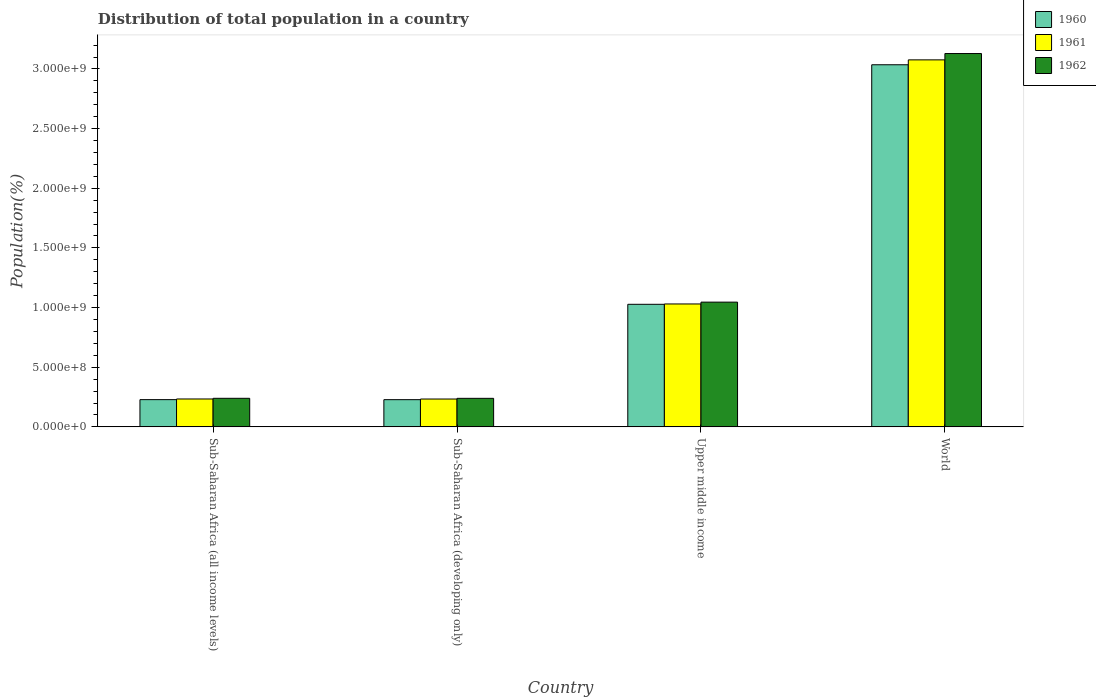Are the number of bars per tick equal to the number of legend labels?
Offer a terse response. Yes. Are the number of bars on each tick of the X-axis equal?
Your answer should be compact. Yes. How many bars are there on the 3rd tick from the left?
Provide a succinct answer. 3. What is the label of the 1st group of bars from the left?
Your response must be concise. Sub-Saharan Africa (all income levels). What is the population of in 1962 in Sub-Saharan Africa (all income levels)?
Your answer should be very brief. 2.39e+08. Across all countries, what is the maximum population of in 1961?
Give a very brief answer. 3.08e+09. Across all countries, what is the minimum population of in 1961?
Provide a short and direct response. 2.33e+08. In which country was the population of in 1960 minimum?
Keep it short and to the point. Sub-Saharan Africa (developing only). What is the total population of in 1961 in the graph?
Offer a terse response. 4.57e+09. What is the difference between the population of in 1960 in Sub-Saharan Africa (developing only) and that in World?
Your response must be concise. -2.81e+09. What is the difference between the population of in 1960 in Sub-Saharan Africa (all income levels) and the population of in 1962 in Sub-Saharan Africa (developing only)?
Your response must be concise. -1.08e+07. What is the average population of in 1961 per country?
Make the answer very short. 1.14e+09. What is the difference between the population of of/in 1962 and population of of/in 1960 in World?
Provide a short and direct response. 9.40e+07. In how many countries, is the population of in 1961 greater than 300000000 %?
Offer a very short reply. 2. What is the ratio of the population of in 1960 in Sub-Saharan Africa (developing only) to that in World?
Your answer should be very brief. 0.08. Is the population of in 1960 in Upper middle income less than that in World?
Ensure brevity in your answer.  Yes. Is the difference between the population of in 1962 in Sub-Saharan Africa (developing only) and World greater than the difference between the population of in 1960 in Sub-Saharan Africa (developing only) and World?
Give a very brief answer. No. What is the difference between the highest and the second highest population of in 1961?
Ensure brevity in your answer.  2.05e+09. What is the difference between the highest and the lowest population of in 1961?
Keep it short and to the point. 2.84e+09. Is the sum of the population of in 1961 in Sub-Saharan Africa (all income levels) and World greater than the maximum population of in 1960 across all countries?
Give a very brief answer. Yes. What does the 2nd bar from the left in Sub-Saharan Africa (all income levels) represents?
Provide a short and direct response. 1961. What does the 2nd bar from the right in Upper middle income represents?
Offer a very short reply. 1961. Are all the bars in the graph horizontal?
Provide a succinct answer. No. How many countries are there in the graph?
Offer a very short reply. 4. What is the difference between two consecutive major ticks on the Y-axis?
Your answer should be compact. 5.00e+08. Are the values on the major ticks of Y-axis written in scientific E-notation?
Your answer should be compact. Yes. Does the graph contain grids?
Your answer should be very brief. No. Where does the legend appear in the graph?
Ensure brevity in your answer.  Top right. What is the title of the graph?
Provide a short and direct response. Distribution of total population in a country. What is the label or title of the Y-axis?
Provide a short and direct response. Population(%). What is the Population(%) of 1960 in Sub-Saharan Africa (all income levels)?
Provide a short and direct response. 2.28e+08. What is the Population(%) of 1961 in Sub-Saharan Africa (all income levels)?
Keep it short and to the point. 2.34e+08. What is the Population(%) of 1962 in Sub-Saharan Africa (all income levels)?
Provide a succinct answer. 2.39e+08. What is the Population(%) of 1960 in Sub-Saharan Africa (developing only)?
Make the answer very short. 2.28e+08. What is the Population(%) of 1961 in Sub-Saharan Africa (developing only)?
Provide a short and direct response. 2.33e+08. What is the Population(%) of 1962 in Sub-Saharan Africa (developing only)?
Your response must be concise. 2.39e+08. What is the Population(%) in 1960 in Upper middle income?
Your answer should be very brief. 1.03e+09. What is the Population(%) of 1961 in Upper middle income?
Offer a very short reply. 1.03e+09. What is the Population(%) in 1962 in Upper middle income?
Your response must be concise. 1.05e+09. What is the Population(%) of 1960 in World?
Keep it short and to the point. 3.03e+09. What is the Population(%) in 1961 in World?
Give a very brief answer. 3.08e+09. What is the Population(%) in 1962 in World?
Ensure brevity in your answer.  3.13e+09. Across all countries, what is the maximum Population(%) in 1960?
Keep it short and to the point. 3.03e+09. Across all countries, what is the maximum Population(%) in 1961?
Offer a very short reply. 3.08e+09. Across all countries, what is the maximum Population(%) in 1962?
Your answer should be compact. 3.13e+09. Across all countries, what is the minimum Population(%) in 1960?
Keep it short and to the point. 2.28e+08. Across all countries, what is the minimum Population(%) of 1961?
Offer a very short reply. 2.33e+08. Across all countries, what is the minimum Population(%) in 1962?
Provide a short and direct response. 2.39e+08. What is the total Population(%) of 1960 in the graph?
Keep it short and to the point. 4.52e+09. What is the total Population(%) of 1961 in the graph?
Ensure brevity in your answer.  4.57e+09. What is the total Population(%) of 1962 in the graph?
Give a very brief answer. 4.65e+09. What is the difference between the Population(%) of 1960 in Sub-Saharan Africa (all income levels) and that in Sub-Saharan Africa (developing only)?
Offer a terse response. 2.94e+05. What is the difference between the Population(%) in 1961 in Sub-Saharan Africa (all income levels) and that in Sub-Saharan Africa (developing only)?
Your response must be concise. 2.98e+05. What is the difference between the Population(%) of 1962 in Sub-Saharan Africa (all income levels) and that in Sub-Saharan Africa (developing only)?
Your response must be concise. 3.02e+05. What is the difference between the Population(%) of 1960 in Sub-Saharan Africa (all income levels) and that in Upper middle income?
Give a very brief answer. -7.99e+08. What is the difference between the Population(%) in 1961 in Sub-Saharan Africa (all income levels) and that in Upper middle income?
Offer a very short reply. -7.96e+08. What is the difference between the Population(%) of 1962 in Sub-Saharan Africa (all income levels) and that in Upper middle income?
Offer a very short reply. -8.06e+08. What is the difference between the Population(%) of 1960 in Sub-Saharan Africa (all income levels) and that in World?
Provide a short and direct response. -2.81e+09. What is the difference between the Population(%) of 1961 in Sub-Saharan Africa (all income levels) and that in World?
Provide a succinct answer. -2.84e+09. What is the difference between the Population(%) of 1962 in Sub-Saharan Africa (all income levels) and that in World?
Give a very brief answer. -2.89e+09. What is the difference between the Population(%) of 1960 in Sub-Saharan Africa (developing only) and that in Upper middle income?
Your answer should be very brief. -7.99e+08. What is the difference between the Population(%) in 1961 in Sub-Saharan Africa (developing only) and that in Upper middle income?
Give a very brief answer. -7.97e+08. What is the difference between the Population(%) in 1962 in Sub-Saharan Africa (developing only) and that in Upper middle income?
Your answer should be very brief. -8.06e+08. What is the difference between the Population(%) in 1960 in Sub-Saharan Africa (developing only) and that in World?
Make the answer very short. -2.81e+09. What is the difference between the Population(%) in 1961 in Sub-Saharan Africa (developing only) and that in World?
Give a very brief answer. -2.84e+09. What is the difference between the Population(%) in 1962 in Sub-Saharan Africa (developing only) and that in World?
Offer a terse response. -2.89e+09. What is the difference between the Population(%) of 1960 in Upper middle income and that in World?
Offer a terse response. -2.01e+09. What is the difference between the Population(%) in 1961 in Upper middle income and that in World?
Give a very brief answer. -2.05e+09. What is the difference between the Population(%) in 1962 in Upper middle income and that in World?
Give a very brief answer. -2.08e+09. What is the difference between the Population(%) in 1960 in Sub-Saharan Africa (all income levels) and the Population(%) in 1961 in Sub-Saharan Africa (developing only)?
Your answer should be very brief. -5.19e+06. What is the difference between the Population(%) of 1960 in Sub-Saharan Africa (all income levels) and the Population(%) of 1962 in Sub-Saharan Africa (developing only)?
Ensure brevity in your answer.  -1.08e+07. What is the difference between the Population(%) of 1961 in Sub-Saharan Africa (all income levels) and the Population(%) of 1962 in Sub-Saharan Africa (developing only)?
Your answer should be very brief. -5.34e+06. What is the difference between the Population(%) in 1960 in Sub-Saharan Africa (all income levels) and the Population(%) in 1961 in Upper middle income?
Provide a succinct answer. -8.02e+08. What is the difference between the Population(%) in 1960 in Sub-Saharan Africa (all income levels) and the Population(%) in 1962 in Upper middle income?
Give a very brief answer. -8.17e+08. What is the difference between the Population(%) of 1961 in Sub-Saharan Africa (all income levels) and the Population(%) of 1962 in Upper middle income?
Make the answer very short. -8.12e+08. What is the difference between the Population(%) in 1960 in Sub-Saharan Africa (all income levels) and the Population(%) in 1961 in World?
Make the answer very short. -2.85e+09. What is the difference between the Population(%) of 1960 in Sub-Saharan Africa (all income levels) and the Population(%) of 1962 in World?
Your response must be concise. -2.90e+09. What is the difference between the Population(%) in 1961 in Sub-Saharan Africa (all income levels) and the Population(%) in 1962 in World?
Your answer should be very brief. -2.90e+09. What is the difference between the Population(%) of 1960 in Sub-Saharan Africa (developing only) and the Population(%) of 1961 in Upper middle income?
Give a very brief answer. -8.02e+08. What is the difference between the Population(%) in 1960 in Sub-Saharan Africa (developing only) and the Population(%) in 1962 in Upper middle income?
Offer a very short reply. -8.18e+08. What is the difference between the Population(%) of 1961 in Sub-Saharan Africa (developing only) and the Population(%) of 1962 in Upper middle income?
Your response must be concise. -8.12e+08. What is the difference between the Population(%) of 1960 in Sub-Saharan Africa (developing only) and the Population(%) of 1961 in World?
Offer a terse response. -2.85e+09. What is the difference between the Population(%) in 1960 in Sub-Saharan Africa (developing only) and the Population(%) in 1962 in World?
Make the answer very short. -2.90e+09. What is the difference between the Population(%) in 1961 in Sub-Saharan Africa (developing only) and the Population(%) in 1962 in World?
Your response must be concise. -2.90e+09. What is the difference between the Population(%) in 1960 in Upper middle income and the Population(%) in 1961 in World?
Offer a terse response. -2.05e+09. What is the difference between the Population(%) in 1960 in Upper middle income and the Population(%) in 1962 in World?
Offer a very short reply. -2.10e+09. What is the difference between the Population(%) in 1961 in Upper middle income and the Population(%) in 1962 in World?
Your response must be concise. -2.10e+09. What is the average Population(%) of 1960 per country?
Offer a very short reply. 1.13e+09. What is the average Population(%) of 1961 per country?
Your answer should be very brief. 1.14e+09. What is the average Population(%) in 1962 per country?
Your answer should be compact. 1.16e+09. What is the difference between the Population(%) in 1960 and Population(%) in 1961 in Sub-Saharan Africa (all income levels)?
Make the answer very short. -5.49e+06. What is the difference between the Population(%) of 1960 and Population(%) of 1962 in Sub-Saharan Africa (all income levels)?
Provide a short and direct response. -1.11e+07. What is the difference between the Population(%) of 1961 and Population(%) of 1962 in Sub-Saharan Africa (all income levels)?
Provide a short and direct response. -5.64e+06. What is the difference between the Population(%) in 1960 and Population(%) in 1961 in Sub-Saharan Africa (developing only)?
Provide a short and direct response. -5.49e+06. What is the difference between the Population(%) in 1960 and Population(%) in 1962 in Sub-Saharan Africa (developing only)?
Provide a succinct answer. -1.11e+07. What is the difference between the Population(%) of 1961 and Population(%) of 1962 in Sub-Saharan Africa (developing only)?
Your answer should be compact. -5.64e+06. What is the difference between the Population(%) of 1960 and Population(%) of 1961 in Upper middle income?
Offer a terse response. -2.91e+06. What is the difference between the Population(%) in 1960 and Population(%) in 1962 in Upper middle income?
Make the answer very short. -1.82e+07. What is the difference between the Population(%) of 1961 and Population(%) of 1962 in Upper middle income?
Offer a terse response. -1.53e+07. What is the difference between the Population(%) of 1960 and Population(%) of 1961 in World?
Offer a very short reply. -4.11e+07. What is the difference between the Population(%) in 1960 and Population(%) in 1962 in World?
Offer a terse response. -9.40e+07. What is the difference between the Population(%) in 1961 and Population(%) in 1962 in World?
Offer a terse response. -5.30e+07. What is the ratio of the Population(%) in 1960 in Sub-Saharan Africa (all income levels) to that in Upper middle income?
Your answer should be very brief. 0.22. What is the ratio of the Population(%) of 1961 in Sub-Saharan Africa (all income levels) to that in Upper middle income?
Keep it short and to the point. 0.23. What is the ratio of the Population(%) in 1962 in Sub-Saharan Africa (all income levels) to that in Upper middle income?
Provide a short and direct response. 0.23. What is the ratio of the Population(%) of 1960 in Sub-Saharan Africa (all income levels) to that in World?
Provide a short and direct response. 0.08. What is the ratio of the Population(%) in 1961 in Sub-Saharan Africa (all income levels) to that in World?
Offer a terse response. 0.08. What is the ratio of the Population(%) in 1962 in Sub-Saharan Africa (all income levels) to that in World?
Offer a terse response. 0.08. What is the ratio of the Population(%) in 1960 in Sub-Saharan Africa (developing only) to that in Upper middle income?
Provide a succinct answer. 0.22. What is the ratio of the Population(%) of 1961 in Sub-Saharan Africa (developing only) to that in Upper middle income?
Offer a terse response. 0.23. What is the ratio of the Population(%) in 1962 in Sub-Saharan Africa (developing only) to that in Upper middle income?
Ensure brevity in your answer.  0.23. What is the ratio of the Population(%) in 1960 in Sub-Saharan Africa (developing only) to that in World?
Your answer should be very brief. 0.08. What is the ratio of the Population(%) of 1961 in Sub-Saharan Africa (developing only) to that in World?
Make the answer very short. 0.08. What is the ratio of the Population(%) of 1962 in Sub-Saharan Africa (developing only) to that in World?
Offer a terse response. 0.08. What is the ratio of the Population(%) of 1960 in Upper middle income to that in World?
Ensure brevity in your answer.  0.34. What is the ratio of the Population(%) in 1961 in Upper middle income to that in World?
Offer a terse response. 0.33. What is the ratio of the Population(%) of 1962 in Upper middle income to that in World?
Offer a very short reply. 0.33. What is the difference between the highest and the second highest Population(%) in 1960?
Make the answer very short. 2.01e+09. What is the difference between the highest and the second highest Population(%) in 1961?
Provide a succinct answer. 2.05e+09. What is the difference between the highest and the second highest Population(%) of 1962?
Your answer should be compact. 2.08e+09. What is the difference between the highest and the lowest Population(%) in 1960?
Give a very brief answer. 2.81e+09. What is the difference between the highest and the lowest Population(%) in 1961?
Provide a short and direct response. 2.84e+09. What is the difference between the highest and the lowest Population(%) in 1962?
Give a very brief answer. 2.89e+09. 